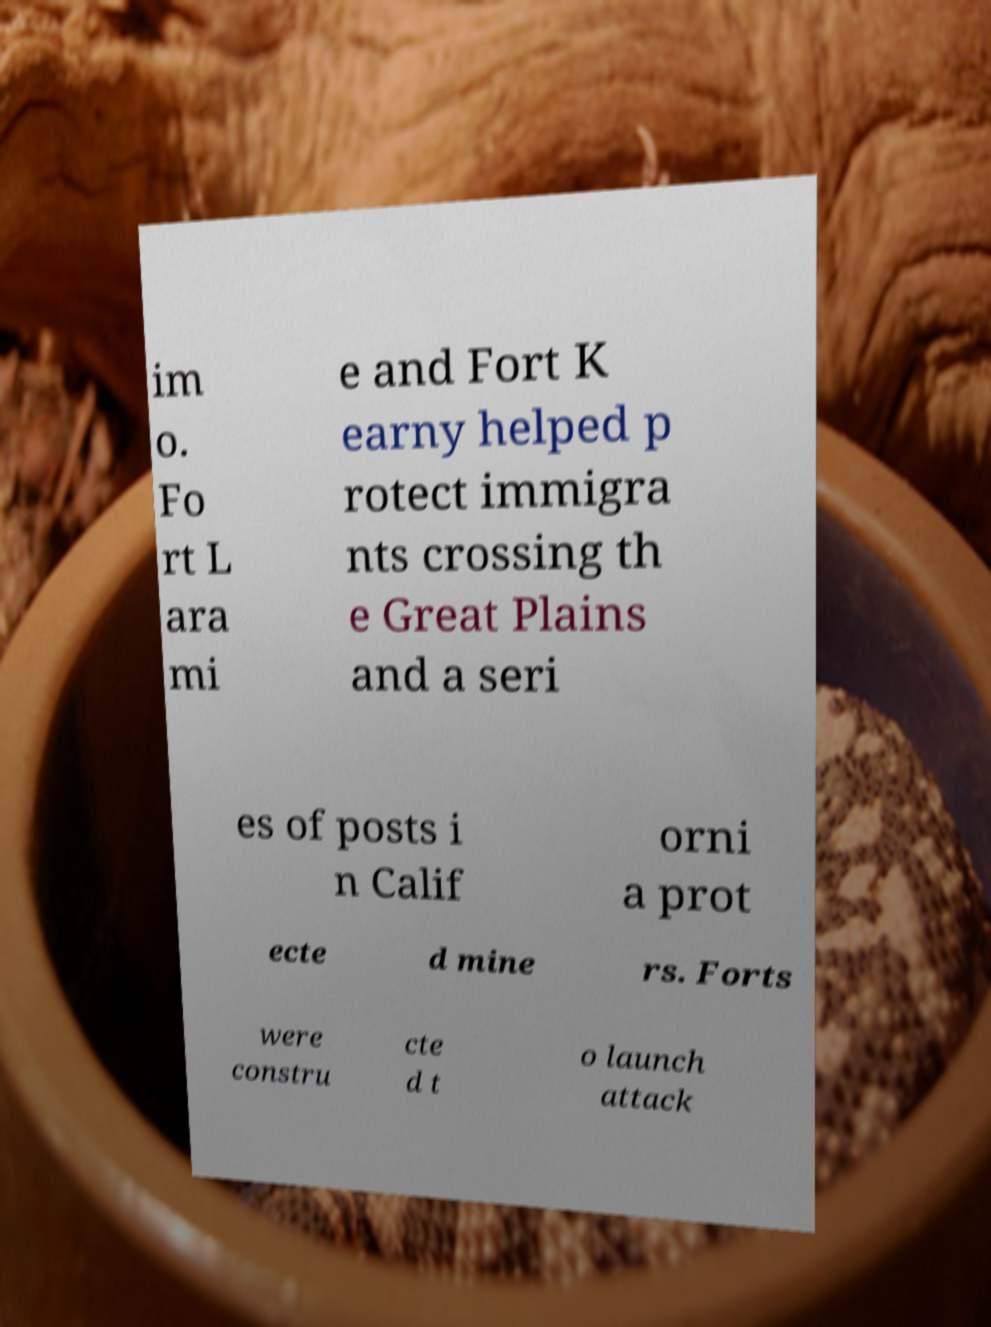Can you accurately transcribe the text from the provided image for me? im o. Fo rt L ara mi e and Fort K earny helped p rotect immigra nts crossing th e Great Plains and a seri es of posts i n Calif orni a prot ecte d mine rs. Forts were constru cte d t o launch attack 